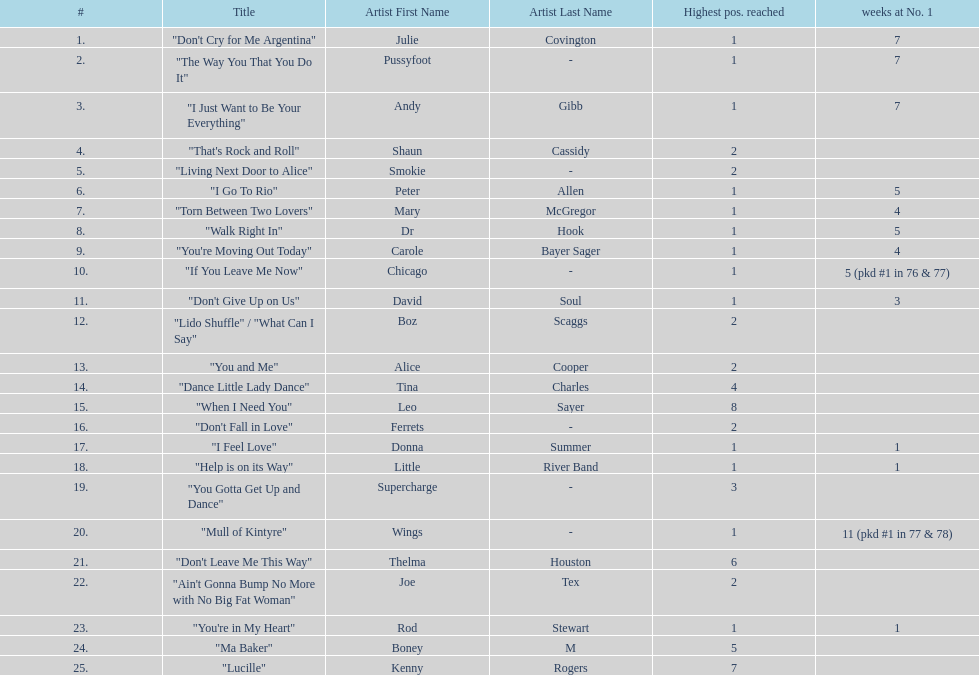How long is the longest amount of time spent at number 1? 11 (pkd #1 in 77 & 78). What song spent 11 weeks at number 1? "Mull of Kintyre". What band had a number 1 hit with this song? Wings. 